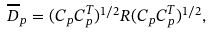Convert formula to latex. <formula><loc_0><loc_0><loc_500><loc_500>\overline { D } _ { p } = ( C _ { p } C _ { p } ^ { T } ) ^ { 1 / 2 } R ( C _ { p } C _ { p } ^ { T } ) ^ { 1 / 2 } ,</formula> 